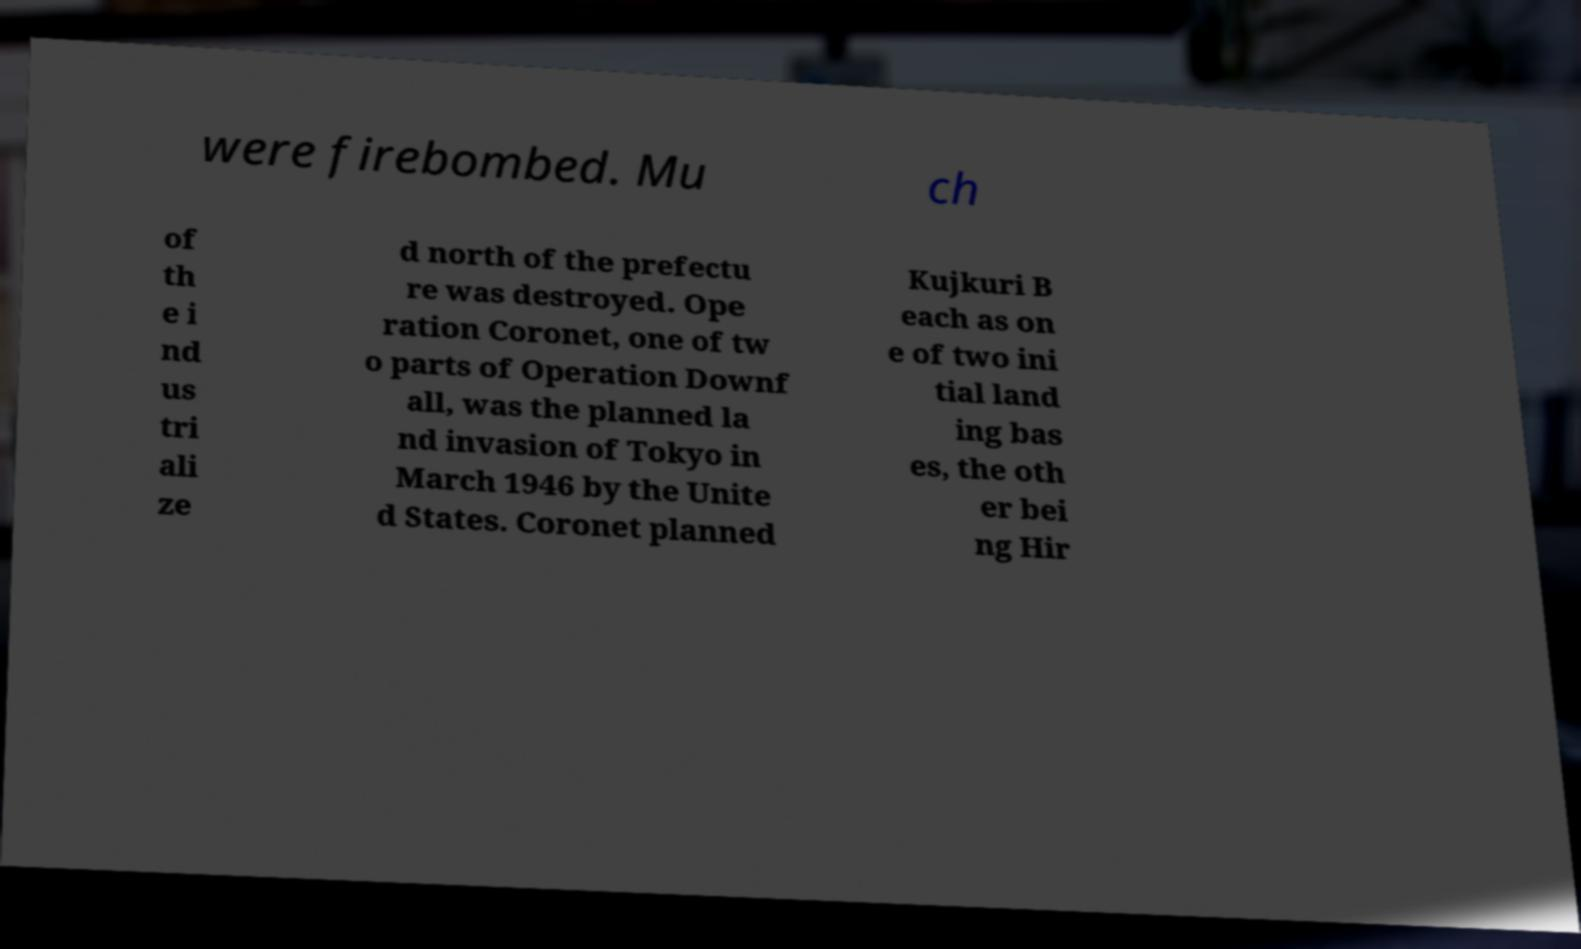For documentation purposes, I need the text within this image transcribed. Could you provide that? were firebombed. Mu ch of th e i nd us tri ali ze d north of the prefectu re was destroyed. Ope ration Coronet, one of tw o parts of Operation Downf all, was the planned la nd invasion of Tokyo in March 1946 by the Unite d States. Coronet planned Kujkuri B each as on e of two ini tial land ing bas es, the oth er bei ng Hir 